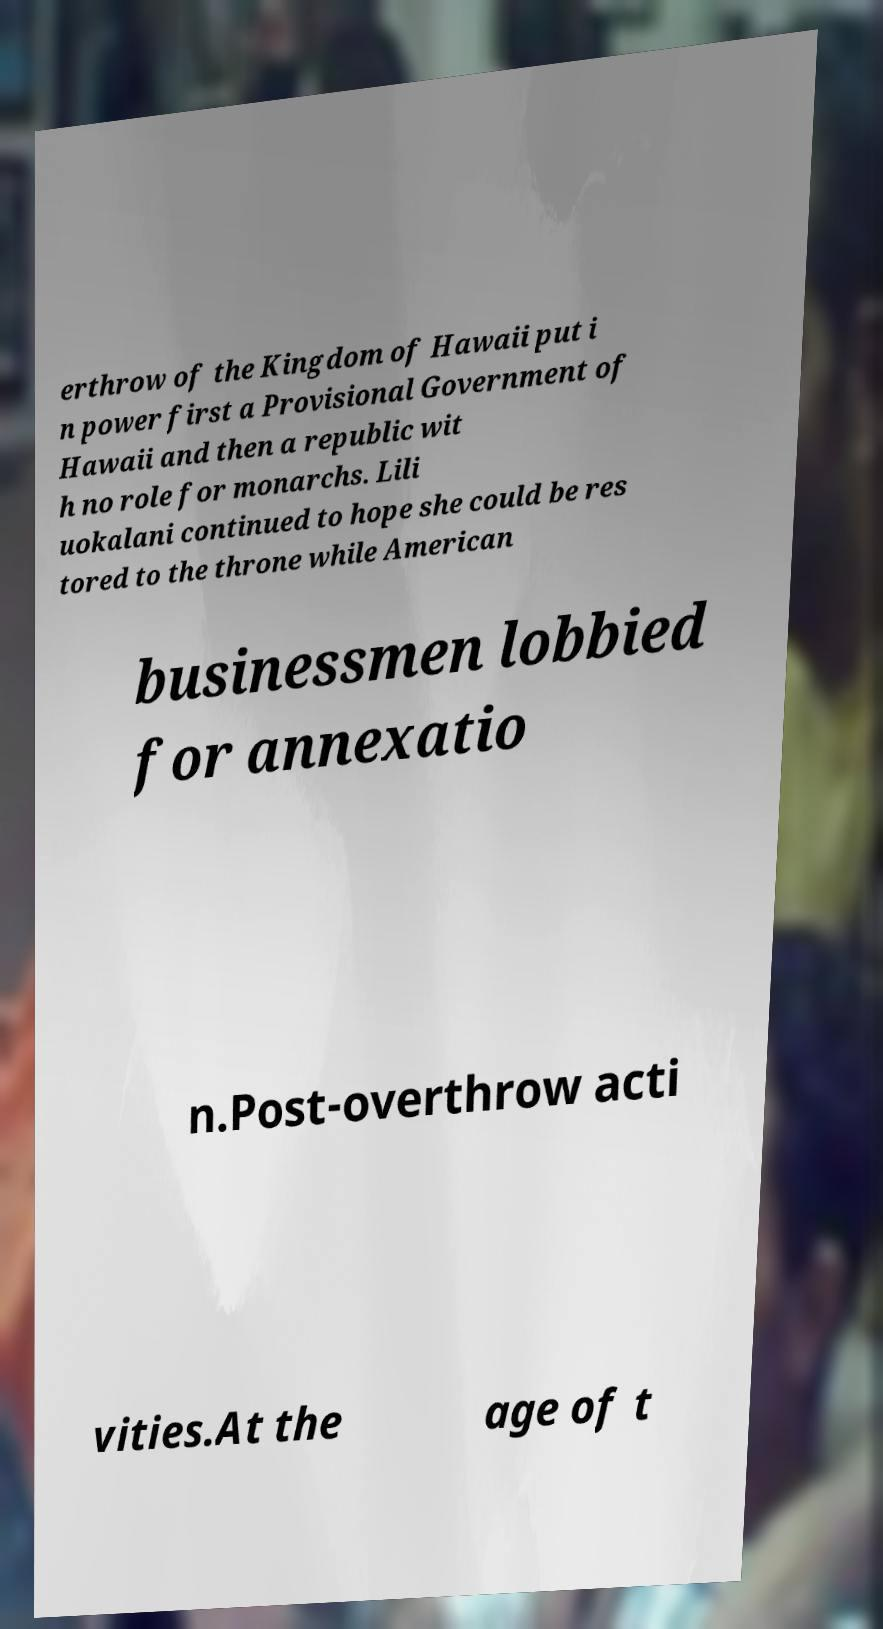I need the written content from this picture converted into text. Can you do that? erthrow of the Kingdom of Hawaii put i n power first a Provisional Government of Hawaii and then a republic wit h no role for monarchs. Lili uokalani continued to hope she could be res tored to the throne while American businessmen lobbied for annexatio n.Post-overthrow acti vities.At the age of t 